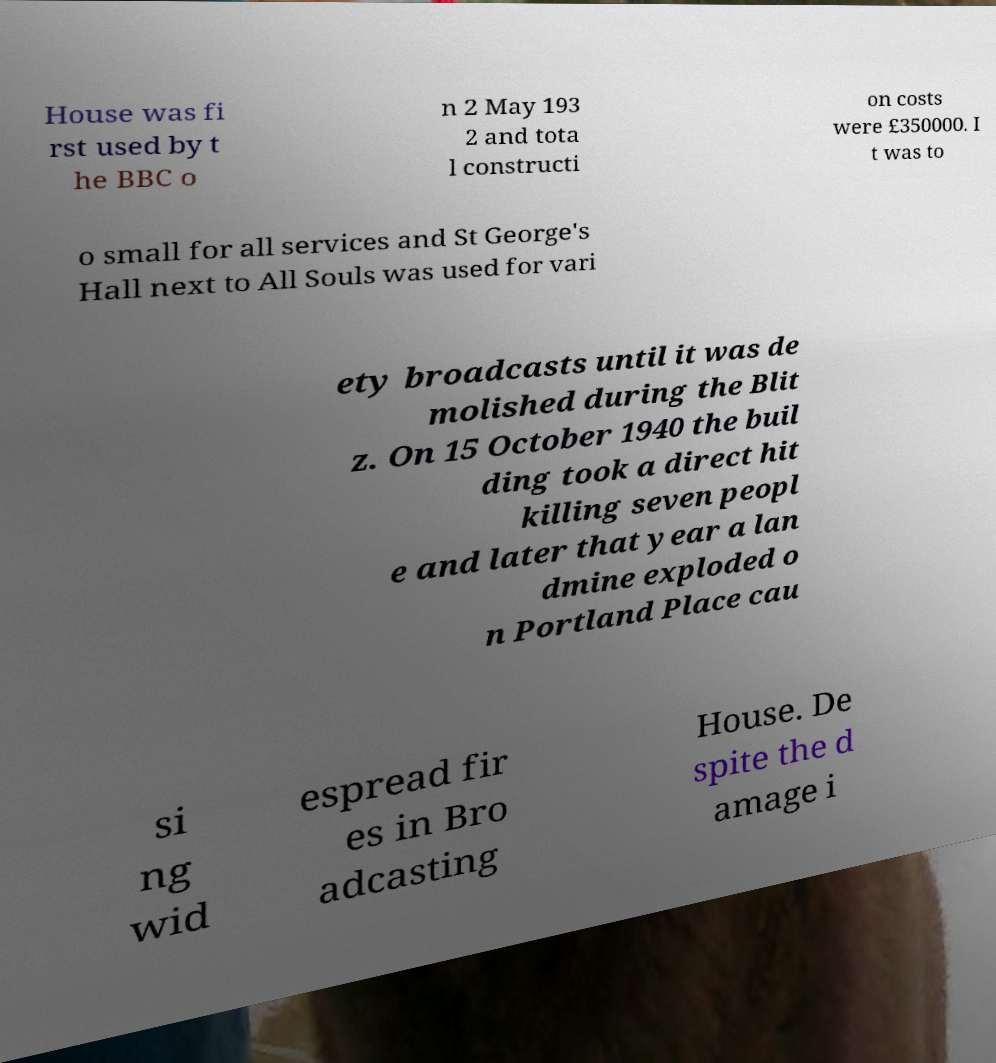Please read and relay the text visible in this image. What does it say? House was fi rst used by t he BBC o n 2 May 193 2 and tota l constructi on costs were £350000. I t was to o small for all services and St George's Hall next to All Souls was used for vari ety broadcasts until it was de molished during the Blit z. On 15 October 1940 the buil ding took a direct hit killing seven peopl e and later that year a lan dmine exploded o n Portland Place cau si ng wid espread fir es in Bro adcasting House. De spite the d amage i 